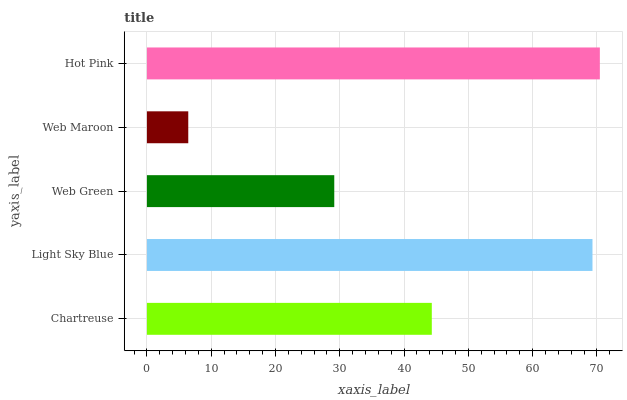Is Web Maroon the minimum?
Answer yes or no. Yes. Is Hot Pink the maximum?
Answer yes or no. Yes. Is Light Sky Blue the minimum?
Answer yes or no. No. Is Light Sky Blue the maximum?
Answer yes or no. No. Is Light Sky Blue greater than Chartreuse?
Answer yes or no. Yes. Is Chartreuse less than Light Sky Blue?
Answer yes or no. Yes. Is Chartreuse greater than Light Sky Blue?
Answer yes or no. No. Is Light Sky Blue less than Chartreuse?
Answer yes or no. No. Is Chartreuse the high median?
Answer yes or no. Yes. Is Chartreuse the low median?
Answer yes or no. Yes. Is Light Sky Blue the high median?
Answer yes or no. No. Is Light Sky Blue the low median?
Answer yes or no. No. 